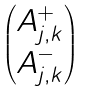Convert formula to latex. <formula><loc_0><loc_0><loc_500><loc_500>\begin{pmatrix} A _ { j , k } ^ { + } \\ A _ { j , k } ^ { - } \end{pmatrix}</formula> 